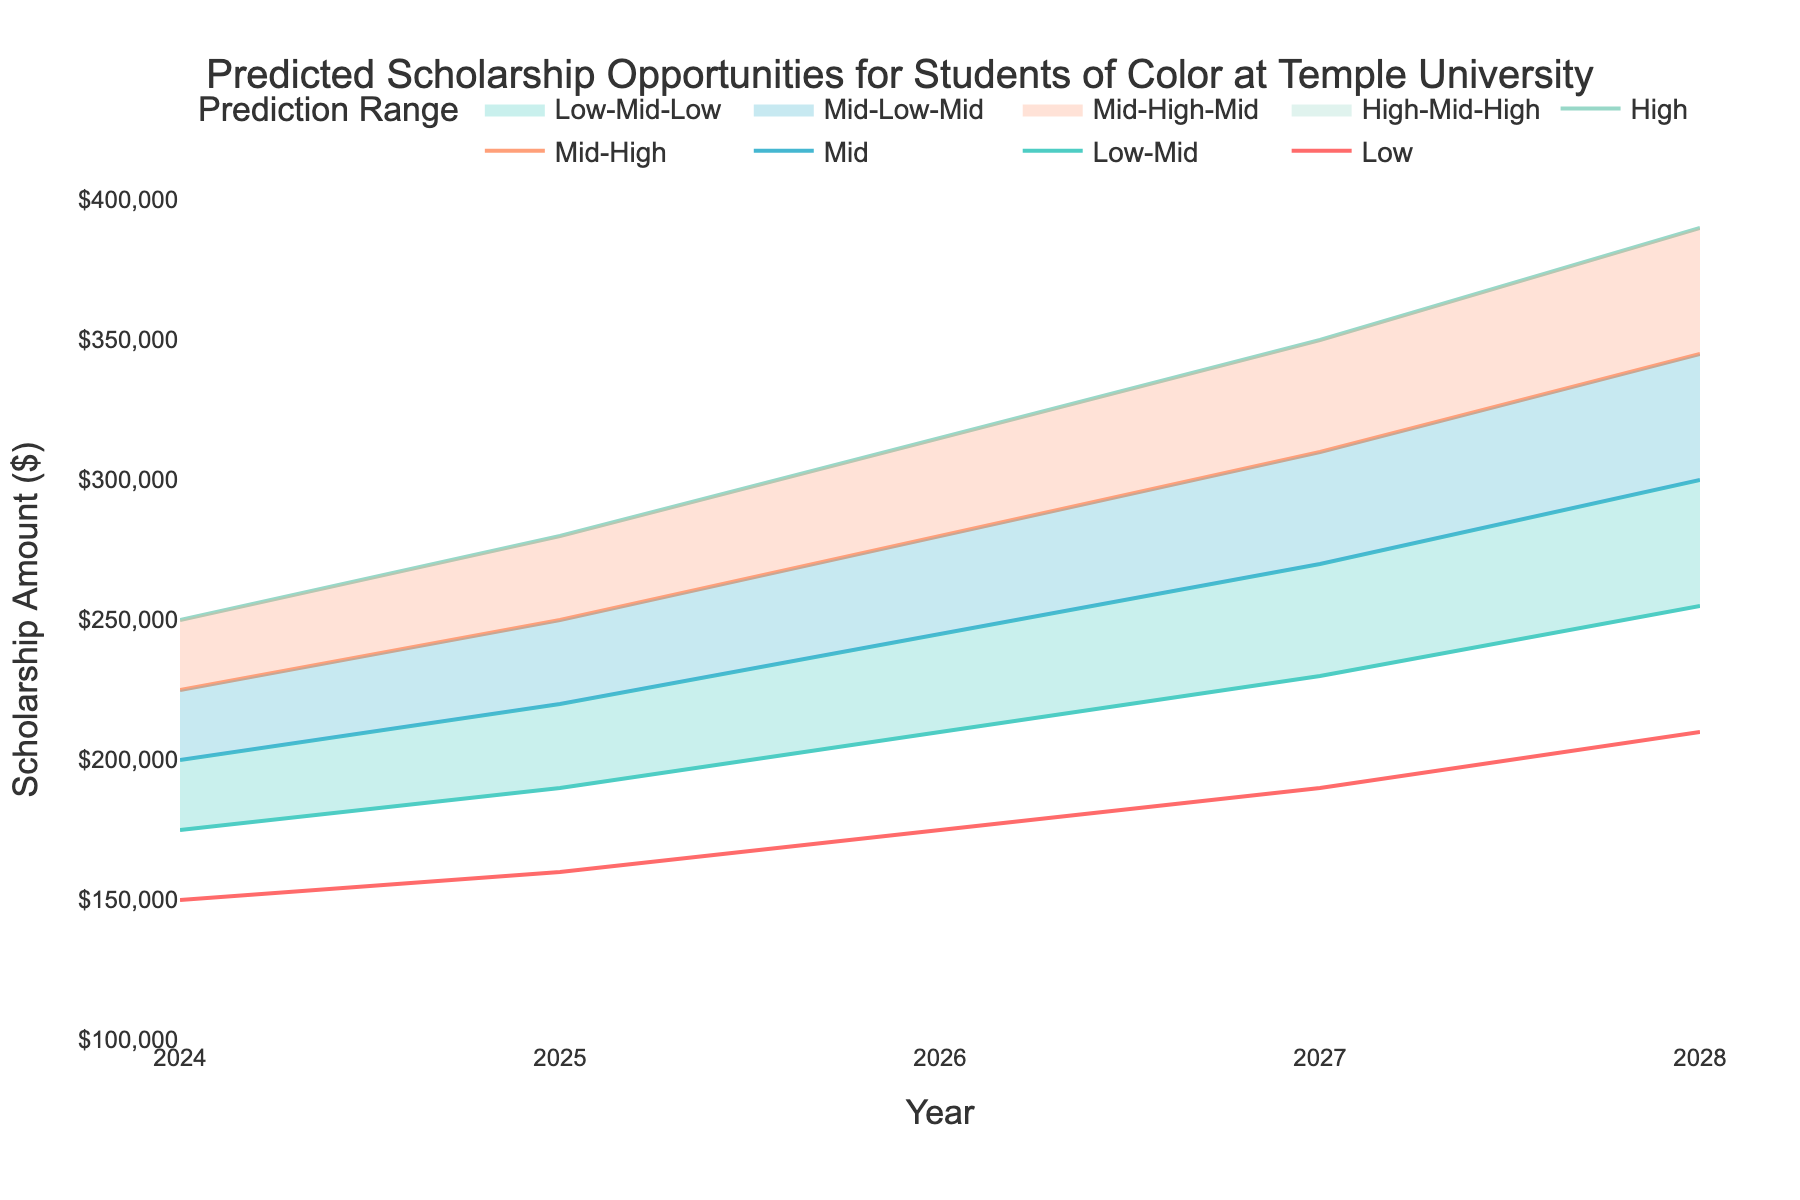What is the predicted scholarship amount in 2025 according to the Mid-High scenario? According to the Mid-High line in 2025, the predicted scholarship amount is 250,000 dollars.
Answer: 250,000 dollars Which year's High prediction reaches 315,000 dollars? The High prediction reaches 315,000 dollars in 2026, as indicated by the corresponding year on the x-axis and the value on the y-axis.
Answer: 2026 How much is the predicted increase in the High scenario from 2024 to 2028? The High scenario amount is 250,000 dollars in 2024 and 390,000 dollars in 2028. The increase is 390,000 - 250,000 = 140,000 dollars.
Answer: 140,000 dollars In which year does the Mid scenario predict scholarships to surpass 200,000 dollars? According to the Mid line, the predicted scholarship amount surpasses 200,000 dollars in 2025.
Answer: 2025 What is the average predicted scholarship for the years 2024 and 2025 in the Low-Mid scenario? The Low-Mid predicted scholarship amount in 2024 is 175,000 dollars and in 2025 is 190,000 dollars. The average is (175,000 + 190,000) / 2 = 182,500 dollars.
Answer: 182,500 dollars Compare the predicted scholarships between the Low and High scenarios in 2027. How much higher is the High prediction compared to the Low? In 2027, the Low prediction is 190,000 dollars and the High prediction is 350,000 dollars. The difference is 350,000 - 190,000 = 160,000 dollars.
Answer: 160,000 dollars Which prediction range shows the smallest increase from 2024 to 2028? The Low scenario shows the smallest increase from 2024 (150,000 dollars) to 2028 (210,000 dollars), which is an increase of 210,000 - 150,000 = 60,000 dollars.
Answer: Low By what percentage does the Mid scenario increase from 2024 to 2028? The Mid scenario amount is 200,000 dollars in 2024 and 300,000 dollars in 2028. The percentage increase is ((300,000 - 200,000) / 200,000) * 100 = 50%.
Answer: 50% During which year is the range between the Low-Mid and Mid-High predictions the widest? The range between Low-Mid and Mid-High is the widest in 2028. For that year, Low-Mid is 255,000 dollars and Mid-High is 345,000 dollars, so the range is 345,000 - 255,000 = 90,000 dollars.
Answer: 2028 What is the overall trend for scholarship opportunities for students of color at Temple University as indicated by the fan chart? The overall trend shows an increasing pattern in scholarship opportunities across all scenarios from 2024 to 2028.
Answer: Increasing pattern 